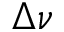Convert formula to latex. <formula><loc_0><loc_0><loc_500><loc_500>\Delta \nu</formula> 